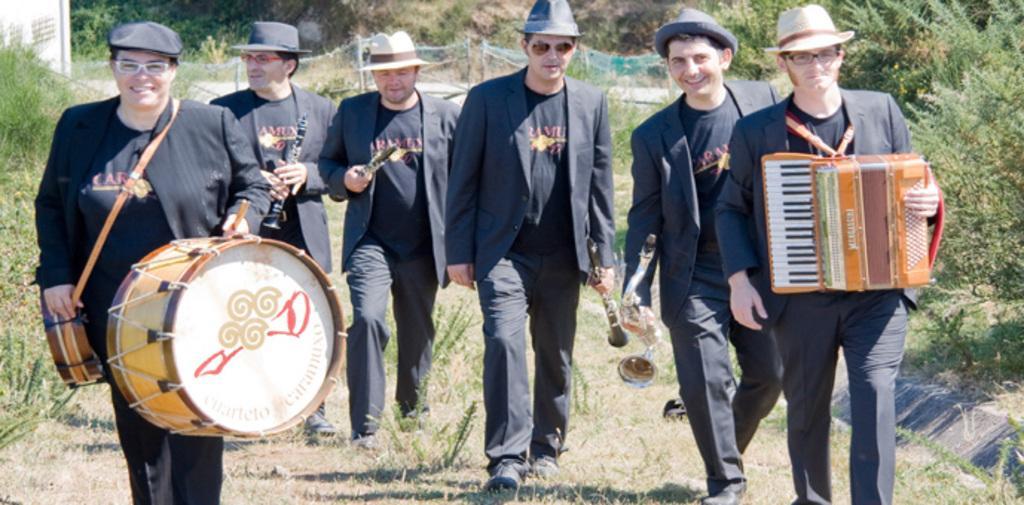How would you summarize this image in a sentence or two? There are six persons walking on a grass road. On the left end a person is holding drums and wearing specs and cap. On the right a person is holding an accordion. In the background there are trees. And all people are wearing hats. And some other musical instruments they are holding. 